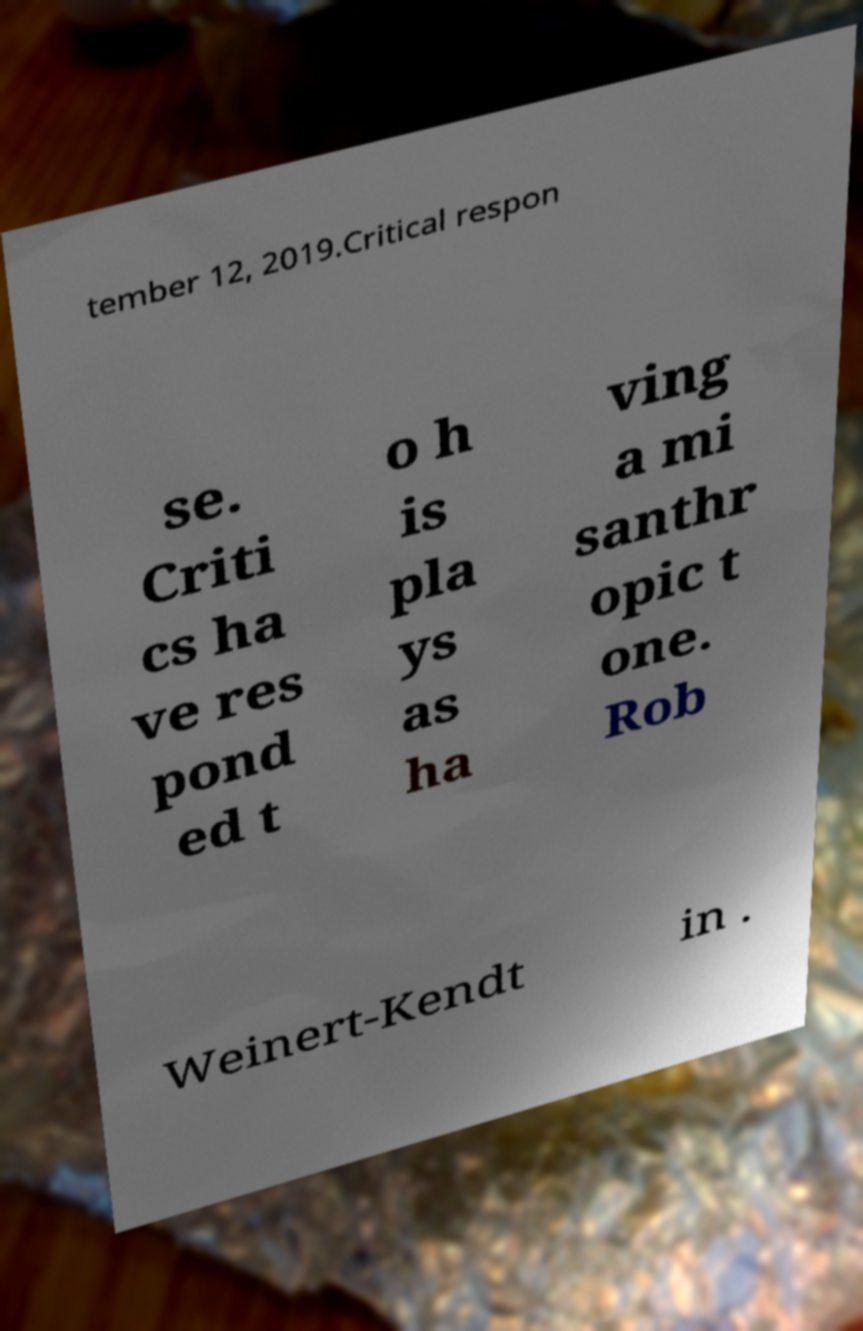What messages or text are displayed in this image? I need them in a readable, typed format. tember 12, 2019.Critical respon se. Criti cs ha ve res pond ed t o h is pla ys as ha ving a mi santhr opic t one. Rob Weinert-Kendt in . 